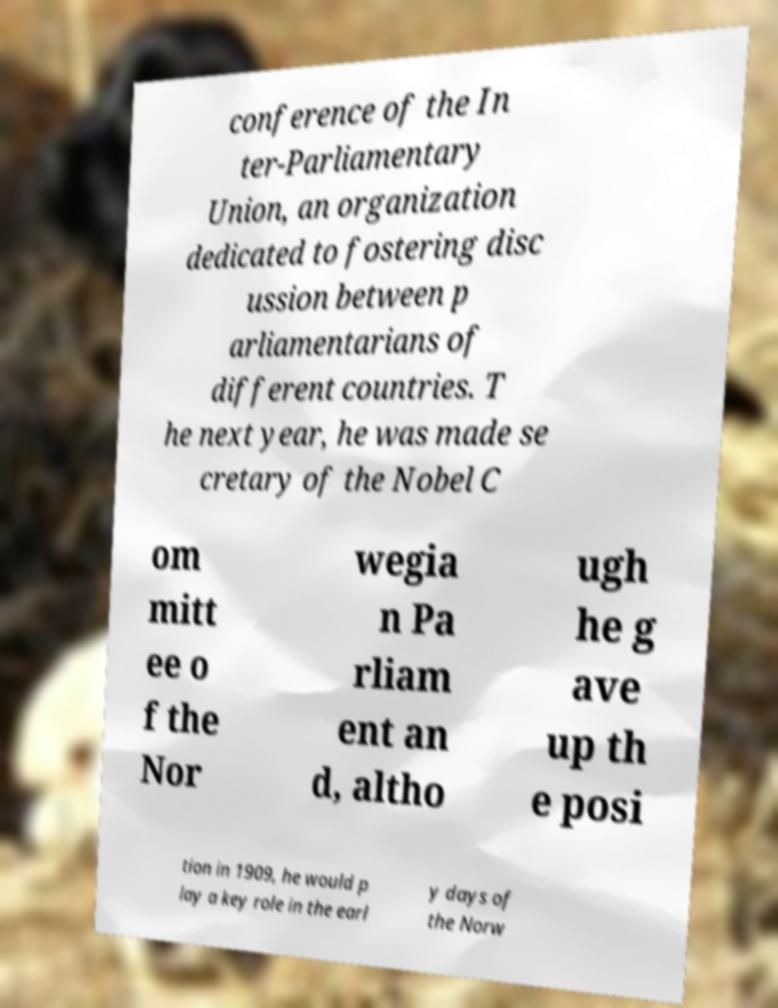What messages or text are displayed in this image? I need them in a readable, typed format. conference of the In ter-Parliamentary Union, an organization dedicated to fostering disc ussion between p arliamentarians of different countries. T he next year, he was made se cretary of the Nobel C om mitt ee o f the Nor wegia n Pa rliam ent an d, altho ugh he g ave up th e posi tion in 1909, he would p lay a key role in the earl y days of the Norw 